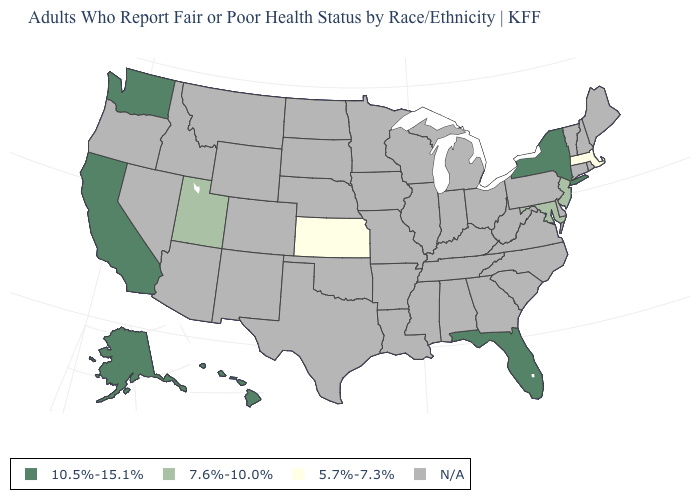What is the value of Vermont?
Quick response, please. N/A. How many symbols are there in the legend?
Be succinct. 4. Is the legend a continuous bar?
Keep it brief. No. Which states have the lowest value in the West?
Answer briefly. Utah. Name the states that have a value in the range N/A?
Give a very brief answer. Alabama, Arizona, Arkansas, Colorado, Connecticut, Delaware, Georgia, Idaho, Illinois, Indiana, Iowa, Kentucky, Louisiana, Maine, Michigan, Minnesota, Mississippi, Missouri, Montana, Nebraska, Nevada, New Hampshire, New Mexico, North Carolina, North Dakota, Ohio, Oklahoma, Oregon, Pennsylvania, Rhode Island, South Carolina, South Dakota, Tennessee, Texas, Vermont, Virginia, West Virginia, Wisconsin, Wyoming. Does the first symbol in the legend represent the smallest category?
Short answer required. No. Is the legend a continuous bar?
Be succinct. No. Name the states that have a value in the range 7.6%-10.0%?
Quick response, please. Maryland, New Jersey, Utah. Among the states that border Vermont , which have the lowest value?
Be succinct. Massachusetts. Does the map have missing data?
Quick response, please. Yes. What is the value of Tennessee?
Give a very brief answer. N/A. What is the value of Massachusetts?
Answer briefly. 5.7%-7.3%. Name the states that have a value in the range N/A?
Write a very short answer. Alabama, Arizona, Arkansas, Colorado, Connecticut, Delaware, Georgia, Idaho, Illinois, Indiana, Iowa, Kentucky, Louisiana, Maine, Michigan, Minnesota, Mississippi, Missouri, Montana, Nebraska, Nevada, New Hampshire, New Mexico, North Carolina, North Dakota, Ohio, Oklahoma, Oregon, Pennsylvania, Rhode Island, South Carolina, South Dakota, Tennessee, Texas, Vermont, Virginia, West Virginia, Wisconsin, Wyoming. 